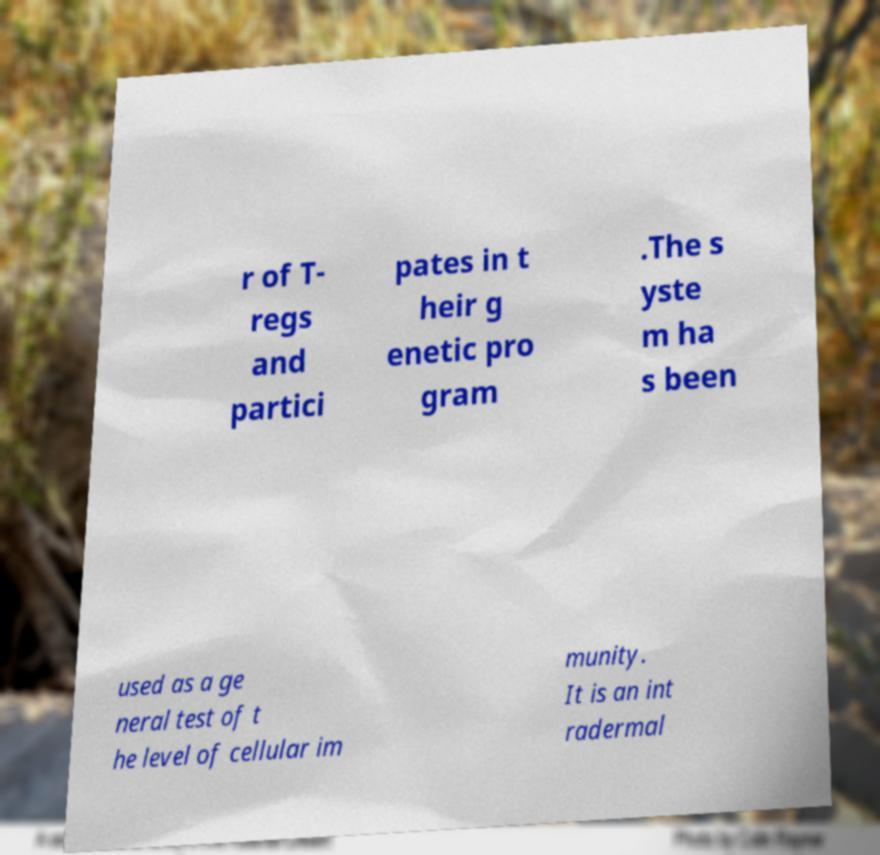Can you read and provide the text displayed in the image?This photo seems to have some interesting text. Can you extract and type it out for me? r of T- regs and partici pates in t heir g enetic pro gram .The s yste m ha s been used as a ge neral test of t he level of cellular im munity. It is an int radermal 